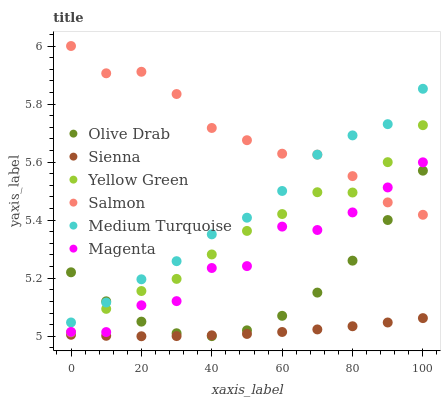Does Sienna have the minimum area under the curve?
Answer yes or no. Yes. Does Salmon have the maximum area under the curve?
Answer yes or no. Yes. Does Salmon have the minimum area under the curve?
Answer yes or no. No. Does Sienna have the maximum area under the curve?
Answer yes or no. No. Is Sienna the smoothest?
Answer yes or no. Yes. Is Magenta the roughest?
Answer yes or no. Yes. Is Salmon the smoothest?
Answer yes or no. No. Is Salmon the roughest?
Answer yes or no. No. Does Sienna have the lowest value?
Answer yes or no. Yes. Does Salmon have the lowest value?
Answer yes or no. No. Does Salmon have the highest value?
Answer yes or no. Yes. Does Sienna have the highest value?
Answer yes or no. No. Is Sienna less than Yellow Green?
Answer yes or no. Yes. Is Salmon greater than Sienna?
Answer yes or no. Yes. Does Yellow Green intersect Salmon?
Answer yes or no. Yes. Is Yellow Green less than Salmon?
Answer yes or no. No. Is Yellow Green greater than Salmon?
Answer yes or no. No. Does Sienna intersect Yellow Green?
Answer yes or no. No. 